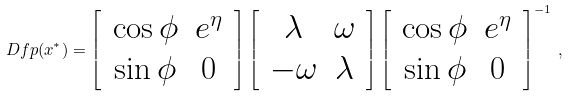<formula> <loc_0><loc_0><loc_500><loc_500>\ D f p ( x ^ { \ast } ) = \left [ \, \begin{array} { c c } \cos \phi & e ^ { \eta } \\ \sin \phi & 0 \end{array} \, \right ] \left [ \, \begin{array} { c c } \lambda & \omega \\ - \omega & \lambda \end{array} \, \right ] \left [ \, \begin{array} { c c } \cos \phi & e ^ { \eta } \\ \sin \phi & 0 \end{array} \, \right ] ^ { - 1 } \, ,</formula> 